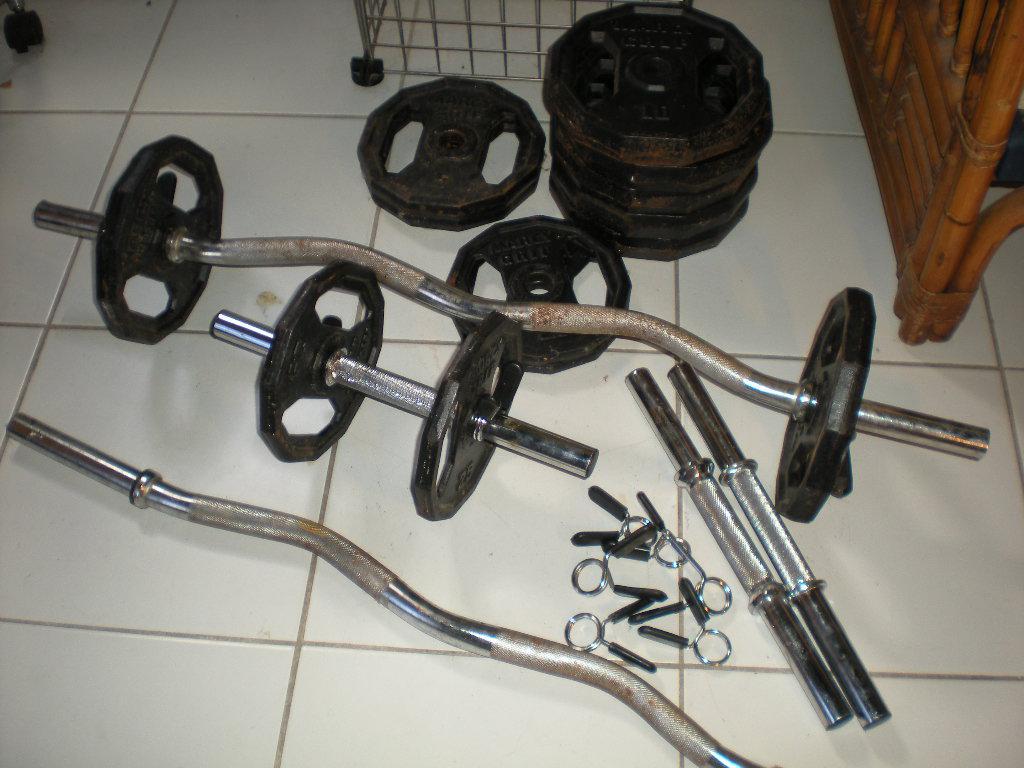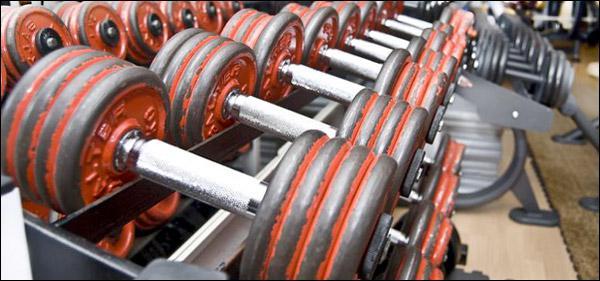The first image is the image on the left, the second image is the image on the right. Examine the images to the left and right. Is the description "In at least one image there is a bar for a bench that has no weights on it." accurate? Answer yes or no. Yes. The first image is the image on the left, the second image is the image on the right. Examine the images to the left and right. Is the description "Each image contains at least ten black dumbbells, and at least one image shows dumbbells stored on a rack." accurate? Answer yes or no. No. 